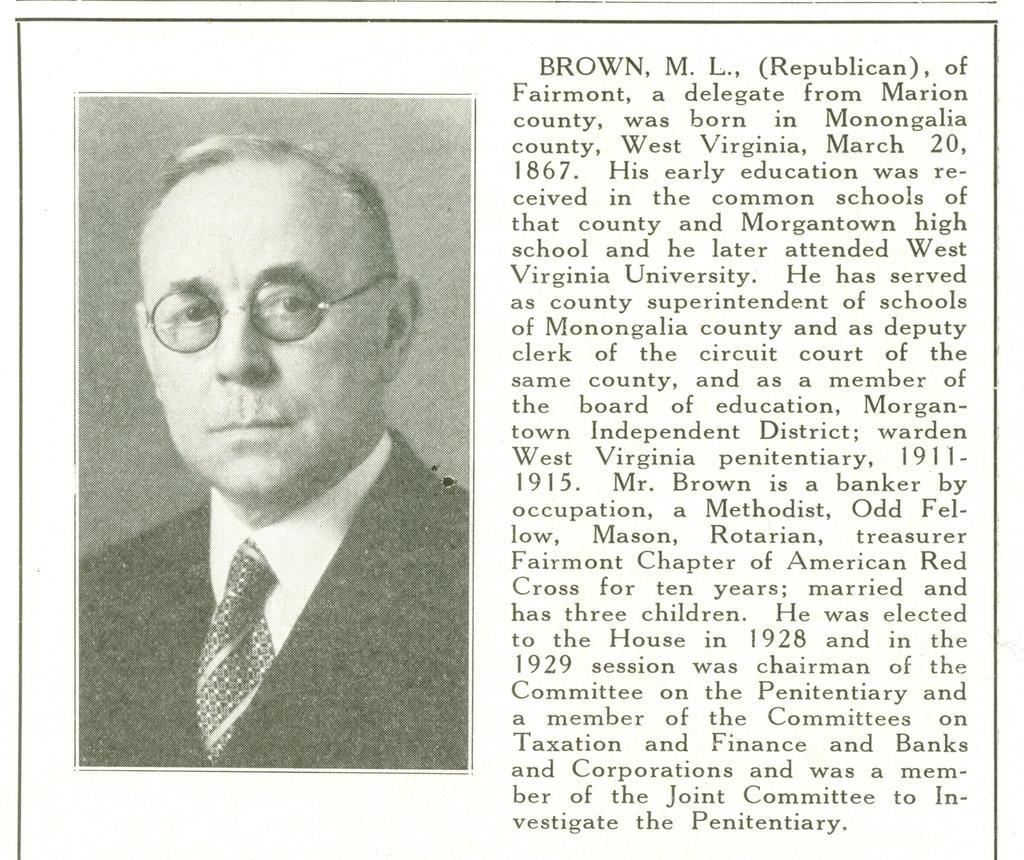What is present on the poster in the image? There is a poster in the image. What can be found on the poster besides the picture? Something is written on the poster. What is depicted in the picture on the poster? There is a picture of a person on the poster. What accessory is the person in the picture wearing? The person in the picture is wearing spectacles. Can you tell me how many stamps are on the person's forehead in the image? There are no stamps present on the person's forehead in the image. What type of relation does the person in the picture have with the person asking the question? The image does not provide any information about the relationship between the person in the picture and the person asking the question. 